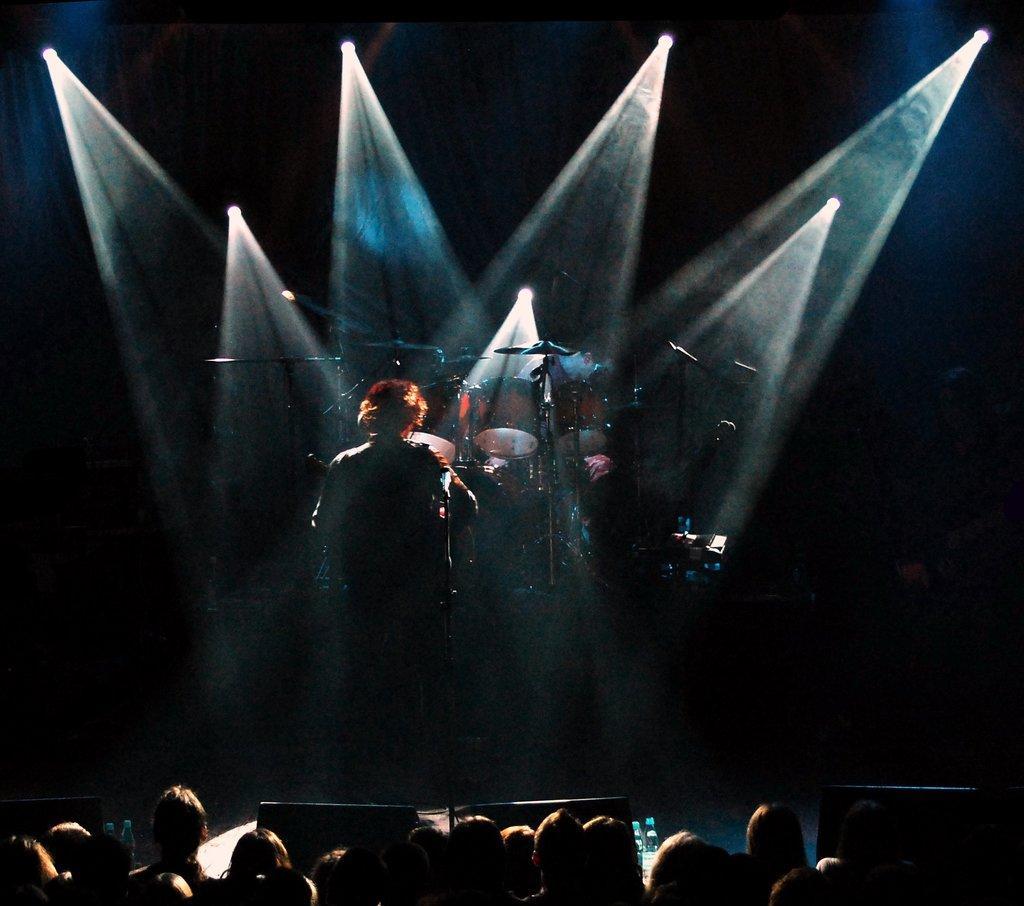In one or two sentences, can you explain what this image depicts? In the picture we can see a man standing on the stage and turning back side and behind him we can see orchestra system and behind it, we can see some lights to the wall which are focused on him and near the stage we can see some people are standing and looking at him. 